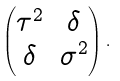<formula> <loc_0><loc_0><loc_500><loc_500>\begin{pmatrix} \tau ^ { 2 } & \delta \\ \delta & \sigma ^ { 2 } \end{pmatrix} .</formula> 